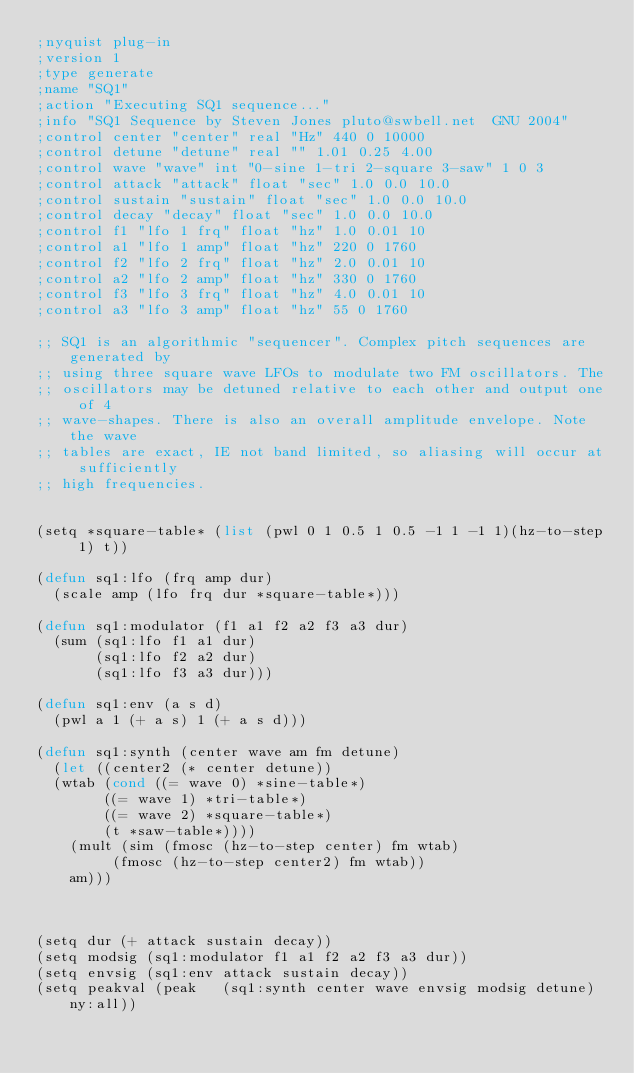Convert code to text. <code><loc_0><loc_0><loc_500><loc_500><_Lisp_>;nyquist plug-in
;version 1
;type generate
;name "SQ1"
;action "Executing SQ1 sequence..."
;info "SQ1 Sequence by Steven Jones pluto@swbell.net  GNU 2004"
;control center "center" real "Hz" 440 0 10000
;control detune "detune" real "" 1.01 0.25 4.00
;control wave "wave" int "0-sine 1-tri 2-square 3-saw" 1 0 3
;control attack "attack" float "sec" 1.0 0.0 10.0
;control sustain "sustain" float "sec" 1.0 0.0 10.0
;control decay "decay" float "sec" 1.0 0.0 10.0
;control f1 "lfo 1 frq" float "hz" 1.0 0.01 10
;control a1 "lfo 1 amp" float "hz" 220 0 1760
;control f2 "lfo 2 frq" float "hz" 2.0 0.01 10
;control a2 "lfo 2 amp" float "hz" 330 0 1760
;control f3 "lfo 3 frq" float "hz" 4.0 0.01 10
;control a3 "lfo 3 amp" float "hz" 55 0 1760

;; SQ1 is an algorithmic "sequencer". Complex pitch sequences are generated by
;; using three square wave LFOs to modulate two FM oscillators. The
;; oscillators may be detuned relative to each other and output one of 4
;; wave-shapes. There is also an overall amplitude envelope. Note the wave
;; tables are exact, IE not band limited, so aliasing will occur at sufficiently
;; high frequencies.


(setq *square-table* (list (pwl 0 1 0.5 1 0.5 -1 1 -1 1)(hz-to-step 1) t))

(defun sq1:lfo (frq amp dur)
  (scale amp (lfo frq dur *square-table*)))

(defun sq1:modulator (f1 a1 f2 a2 f3 a3 dur)
  (sum (sq1:lfo f1 a1 dur)
       (sq1:lfo f2 a2 dur)
       (sq1:lfo f3 a3 dur)))

(defun sq1:env (a s d)
  (pwl a 1 (+ a s) 1 (+ a s d)))

(defun sq1:synth (center wave am fm detune)
  (let ((center2 (* center detune))
	(wtab (cond ((= wave 0) *sine-table*)
		    ((= wave 1) *tri-table*)
		    ((= wave 2) *square-table*)
		    (t *saw-table*))))
    (mult (sim (fmosc (hz-to-step center) fm wtab)
	       (fmosc (hz-to-step center2) fm wtab))
	  am)))



(setq dur (+ attack sustain decay))    
(setq modsig (sq1:modulator f1 a1 f2 a2 f3 a3 dur))
(setq envsig (sq1:env attack sustain decay))
(setq peakval (peak   (sq1:synth center wave envsig modsig detune) ny:all))</code> 